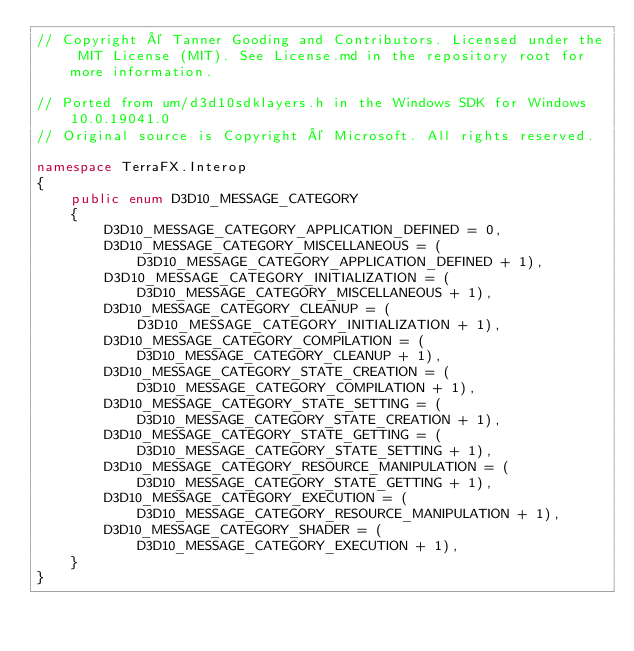Convert code to text. <code><loc_0><loc_0><loc_500><loc_500><_C#_>// Copyright © Tanner Gooding and Contributors. Licensed under the MIT License (MIT). See License.md in the repository root for more information.

// Ported from um/d3d10sdklayers.h in the Windows SDK for Windows 10.0.19041.0
// Original source is Copyright © Microsoft. All rights reserved.

namespace TerraFX.Interop
{
    public enum D3D10_MESSAGE_CATEGORY
    {
        D3D10_MESSAGE_CATEGORY_APPLICATION_DEFINED = 0,
        D3D10_MESSAGE_CATEGORY_MISCELLANEOUS = (D3D10_MESSAGE_CATEGORY_APPLICATION_DEFINED + 1),
        D3D10_MESSAGE_CATEGORY_INITIALIZATION = (D3D10_MESSAGE_CATEGORY_MISCELLANEOUS + 1),
        D3D10_MESSAGE_CATEGORY_CLEANUP = (D3D10_MESSAGE_CATEGORY_INITIALIZATION + 1),
        D3D10_MESSAGE_CATEGORY_COMPILATION = (D3D10_MESSAGE_CATEGORY_CLEANUP + 1),
        D3D10_MESSAGE_CATEGORY_STATE_CREATION = (D3D10_MESSAGE_CATEGORY_COMPILATION + 1),
        D3D10_MESSAGE_CATEGORY_STATE_SETTING = (D3D10_MESSAGE_CATEGORY_STATE_CREATION + 1),
        D3D10_MESSAGE_CATEGORY_STATE_GETTING = (D3D10_MESSAGE_CATEGORY_STATE_SETTING + 1),
        D3D10_MESSAGE_CATEGORY_RESOURCE_MANIPULATION = (D3D10_MESSAGE_CATEGORY_STATE_GETTING + 1),
        D3D10_MESSAGE_CATEGORY_EXECUTION = (D3D10_MESSAGE_CATEGORY_RESOURCE_MANIPULATION + 1),
        D3D10_MESSAGE_CATEGORY_SHADER = (D3D10_MESSAGE_CATEGORY_EXECUTION + 1),
    }
}
</code> 